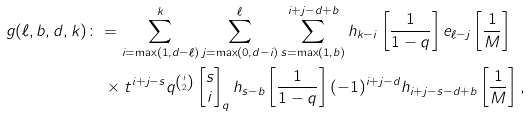Convert formula to latex. <formula><loc_0><loc_0><loc_500><loc_500>g ( \ell , b , d , k ) & \colon = \sum _ { i = \max ( 1 , d - \ell ) } ^ { k } \sum _ { j = \max ( 0 , d - i ) } ^ { \ell } \sum _ { s = \max ( 1 , b ) } ^ { i + j - d + b } h _ { k - i } \left [ \frac { 1 } { 1 - q } \right ] e _ { \ell - j } \left [ \frac { 1 } { M } \right ] \\ & \quad \times t ^ { i + j - s } q ^ { \binom { i } { 2 } } \begin{bmatrix} s \\ i \end{bmatrix} _ { q } h _ { s - b } \left [ \frac { 1 } { 1 - q } \right ] ( - 1 ) ^ { i + j - d } h _ { i + j - s - d + b } \left [ \frac { 1 } { M } \right ] ,</formula> 